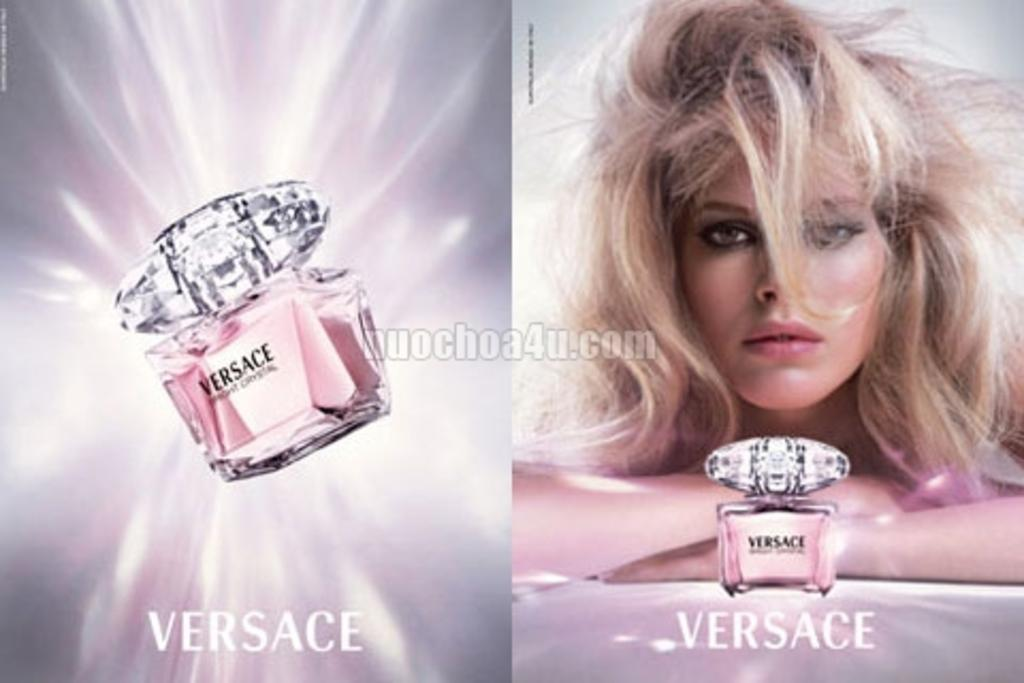<image>
Relay a brief, clear account of the picture shown. a cologne image with a pink color from Versace 